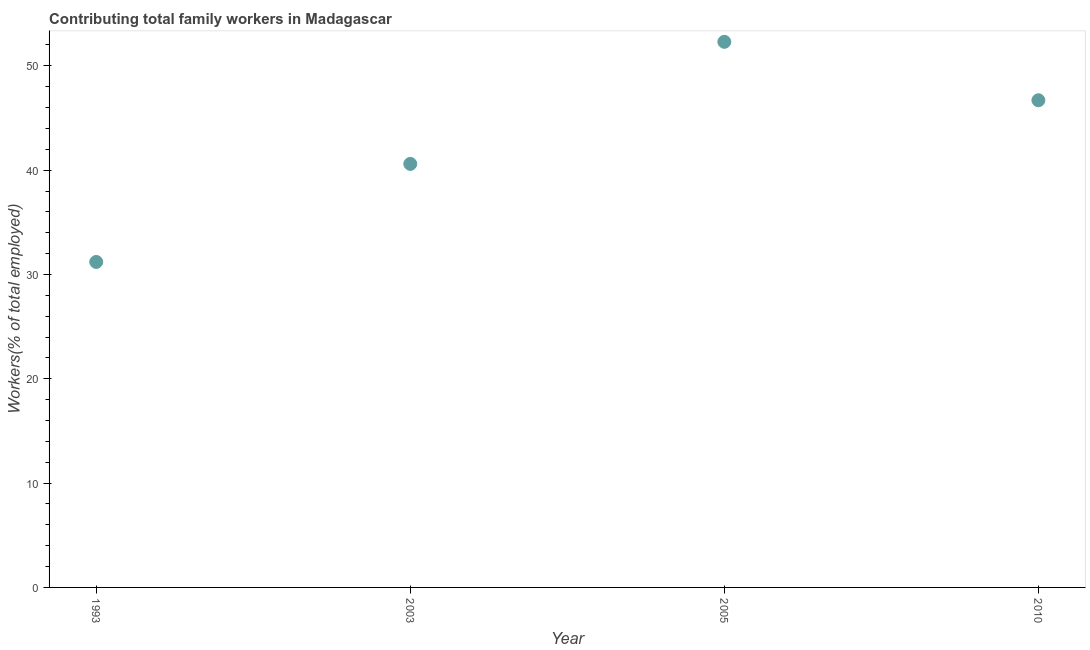What is the contributing family workers in 2005?
Your answer should be compact. 52.3. Across all years, what is the maximum contributing family workers?
Your answer should be compact. 52.3. Across all years, what is the minimum contributing family workers?
Provide a succinct answer. 31.2. In which year was the contributing family workers maximum?
Make the answer very short. 2005. What is the sum of the contributing family workers?
Offer a terse response. 170.8. What is the difference between the contributing family workers in 1993 and 2005?
Give a very brief answer. -21.1. What is the average contributing family workers per year?
Provide a short and direct response. 42.7. What is the median contributing family workers?
Offer a very short reply. 43.65. Do a majority of the years between 2010 and 1993 (inclusive) have contributing family workers greater than 46 %?
Keep it short and to the point. Yes. What is the ratio of the contributing family workers in 1993 to that in 2003?
Keep it short and to the point. 0.77. What is the difference between the highest and the second highest contributing family workers?
Offer a terse response. 5.6. Is the sum of the contributing family workers in 1993 and 2005 greater than the maximum contributing family workers across all years?
Keep it short and to the point. Yes. What is the difference between the highest and the lowest contributing family workers?
Ensure brevity in your answer.  21.1. In how many years, is the contributing family workers greater than the average contributing family workers taken over all years?
Offer a terse response. 2. How many dotlines are there?
Your response must be concise. 1. Are the values on the major ticks of Y-axis written in scientific E-notation?
Provide a short and direct response. No. Does the graph contain grids?
Keep it short and to the point. No. What is the title of the graph?
Your answer should be compact. Contributing total family workers in Madagascar. What is the label or title of the Y-axis?
Make the answer very short. Workers(% of total employed). What is the Workers(% of total employed) in 1993?
Offer a very short reply. 31.2. What is the Workers(% of total employed) in 2003?
Your answer should be compact. 40.6. What is the Workers(% of total employed) in 2005?
Provide a succinct answer. 52.3. What is the Workers(% of total employed) in 2010?
Offer a very short reply. 46.7. What is the difference between the Workers(% of total employed) in 1993 and 2005?
Keep it short and to the point. -21.1. What is the difference between the Workers(% of total employed) in 1993 and 2010?
Provide a short and direct response. -15.5. What is the difference between the Workers(% of total employed) in 2003 and 2005?
Your response must be concise. -11.7. What is the difference between the Workers(% of total employed) in 2003 and 2010?
Provide a short and direct response. -6.1. What is the difference between the Workers(% of total employed) in 2005 and 2010?
Your response must be concise. 5.6. What is the ratio of the Workers(% of total employed) in 1993 to that in 2003?
Your answer should be compact. 0.77. What is the ratio of the Workers(% of total employed) in 1993 to that in 2005?
Keep it short and to the point. 0.6. What is the ratio of the Workers(% of total employed) in 1993 to that in 2010?
Make the answer very short. 0.67. What is the ratio of the Workers(% of total employed) in 2003 to that in 2005?
Give a very brief answer. 0.78. What is the ratio of the Workers(% of total employed) in 2003 to that in 2010?
Your answer should be very brief. 0.87. What is the ratio of the Workers(% of total employed) in 2005 to that in 2010?
Provide a short and direct response. 1.12. 